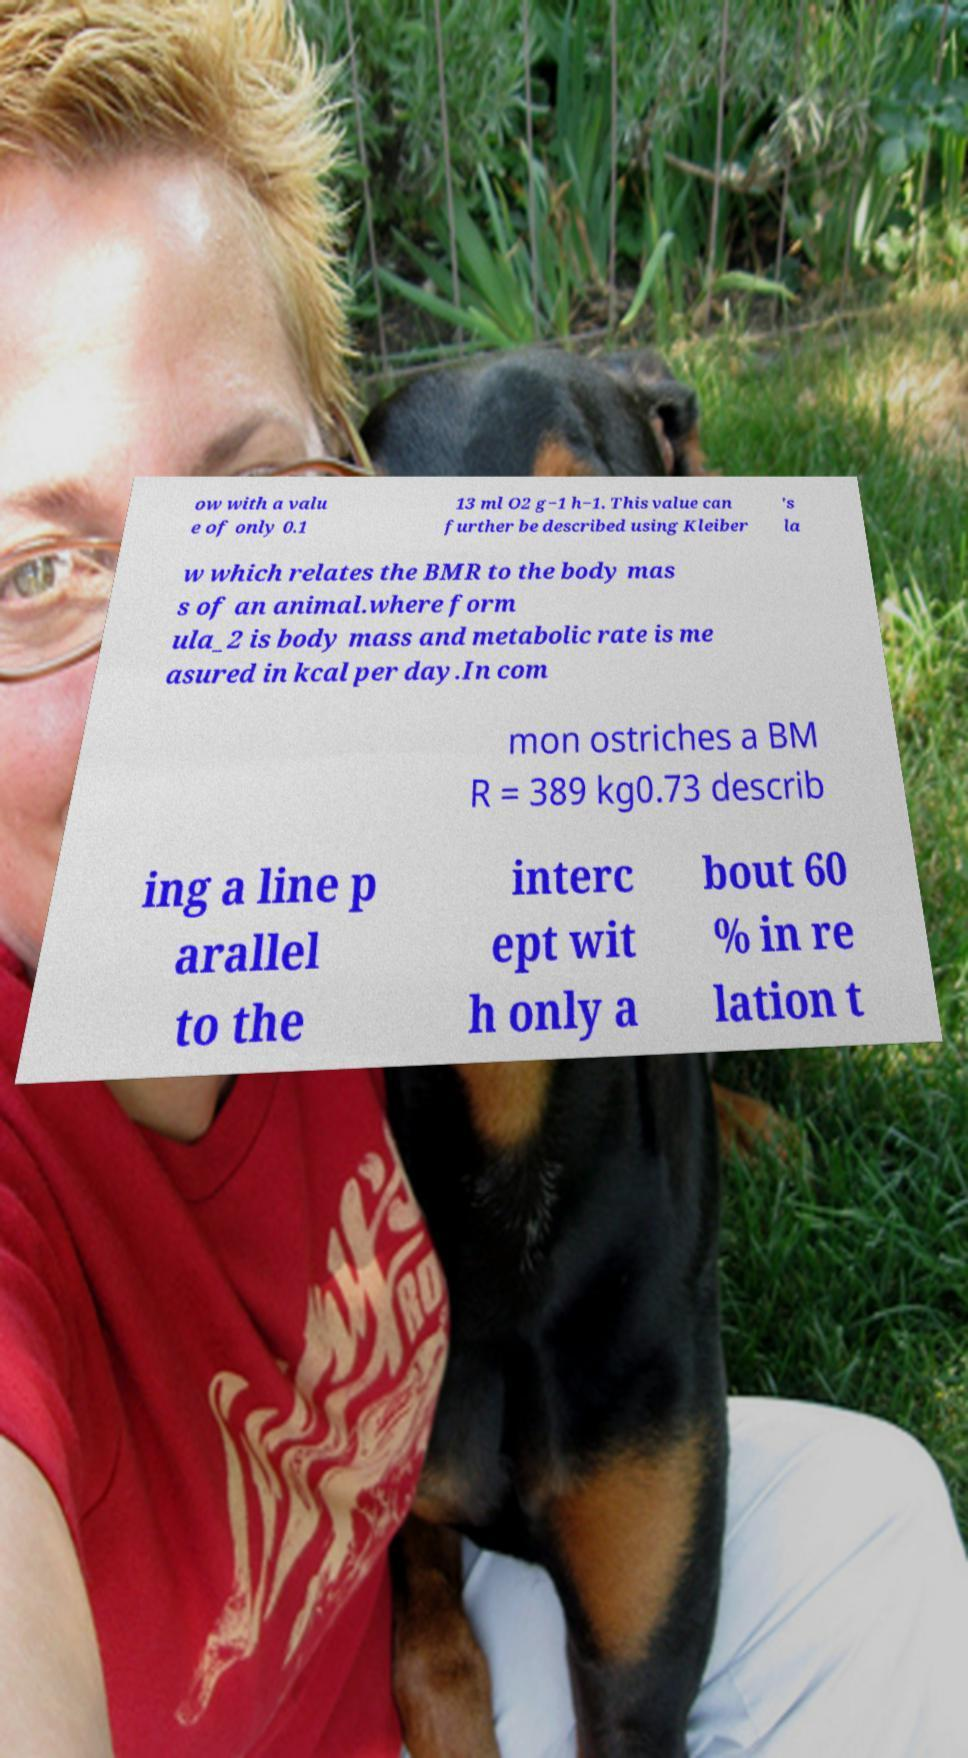I need the written content from this picture converted into text. Can you do that? ow with a valu e of only 0.1 13 ml O2 g−1 h−1. This value can further be described using Kleiber 's la w which relates the BMR to the body mas s of an animal.where form ula_2 is body mass and metabolic rate is me asured in kcal per day.In com mon ostriches a BM R = 389 kg0.73 describ ing a line p arallel to the interc ept wit h only a bout 60 % in re lation t 